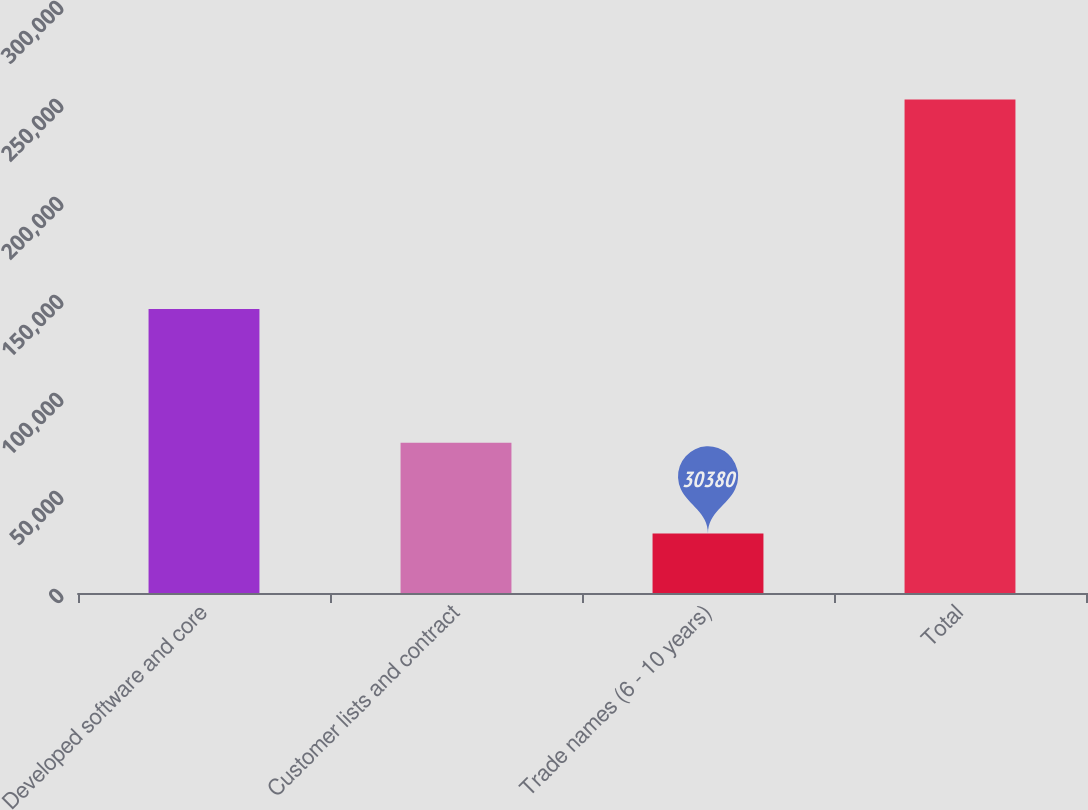Convert chart to OTSL. <chart><loc_0><loc_0><loc_500><loc_500><bar_chart><fcel>Developed software and core<fcel>Customer lists and contract<fcel>Trade names (6 - 10 years)<fcel>Total<nl><fcel>144836<fcel>76630<fcel>30380<fcel>251846<nl></chart> 